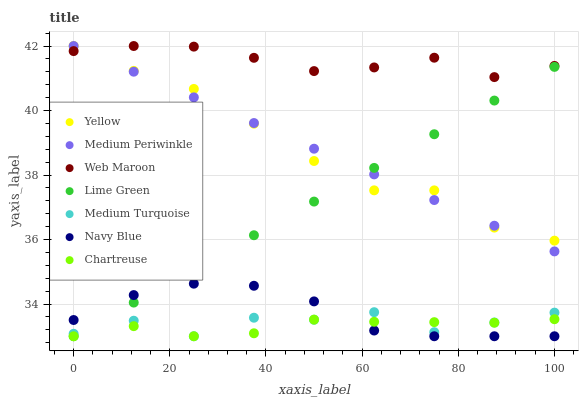Does Chartreuse have the minimum area under the curve?
Answer yes or no. Yes. Does Web Maroon have the maximum area under the curve?
Answer yes or no. Yes. Does Yellow have the minimum area under the curve?
Answer yes or no. No. Does Yellow have the maximum area under the curve?
Answer yes or no. No. Is Medium Periwinkle the smoothest?
Answer yes or no. Yes. Is Medium Turquoise the roughest?
Answer yes or no. Yes. Is Web Maroon the smoothest?
Answer yes or no. No. Is Web Maroon the roughest?
Answer yes or no. No. Does Chartreuse have the lowest value?
Answer yes or no. Yes. Does Yellow have the lowest value?
Answer yes or no. No. Does Yellow have the highest value?
Answer yes or no. Yes. Does Chartreuse have the highest value?
Answer yes or no. No. Is Lime Green less than Web Maroon?
Answer yes or no. Yes. Is Web Maroon greater than Lime Green?
Answer yes or no. Yes. Does Medium Periwinkle intersect Web Maroon?
Answer yes or no. Yes. Is Medium Periwinkle less than Web Maroon?
Answer yes or no. No. Is Medium Periwinkle greater than Web Maroon?
Answer yes or no. No. Does Lime Green intersect Web Maroon?
Answer yes or no. No. 